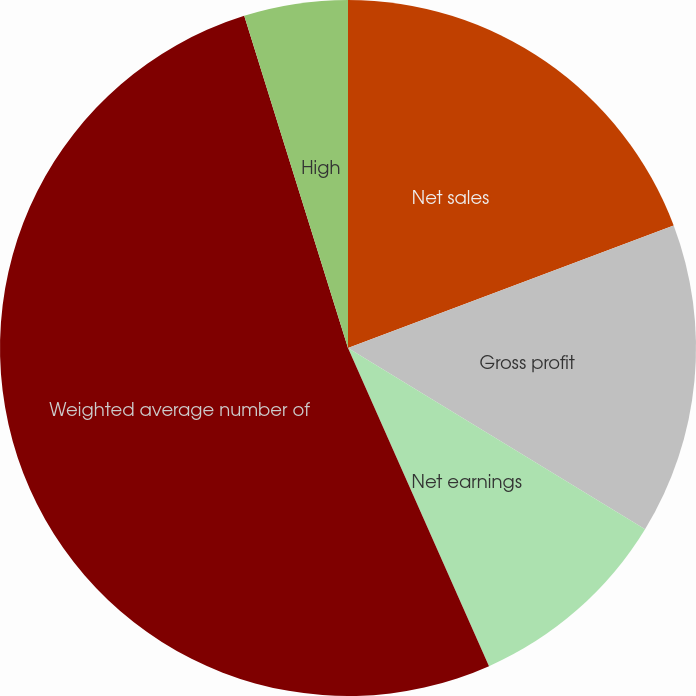<chart> <loc_0><loc_0><loc_500><loc_500><pie_chart><fcel>Net sales<fcel>Gross profit<fcel>Net earnings<fcel>Weighted average number of<fcel>High<fcel>Low<nl><fcel>19.27%<fcel>14.45%<fcel>9.64%<fcel>51.82%<fcel>4.82%<fcel>0.0%<nl></chart> 